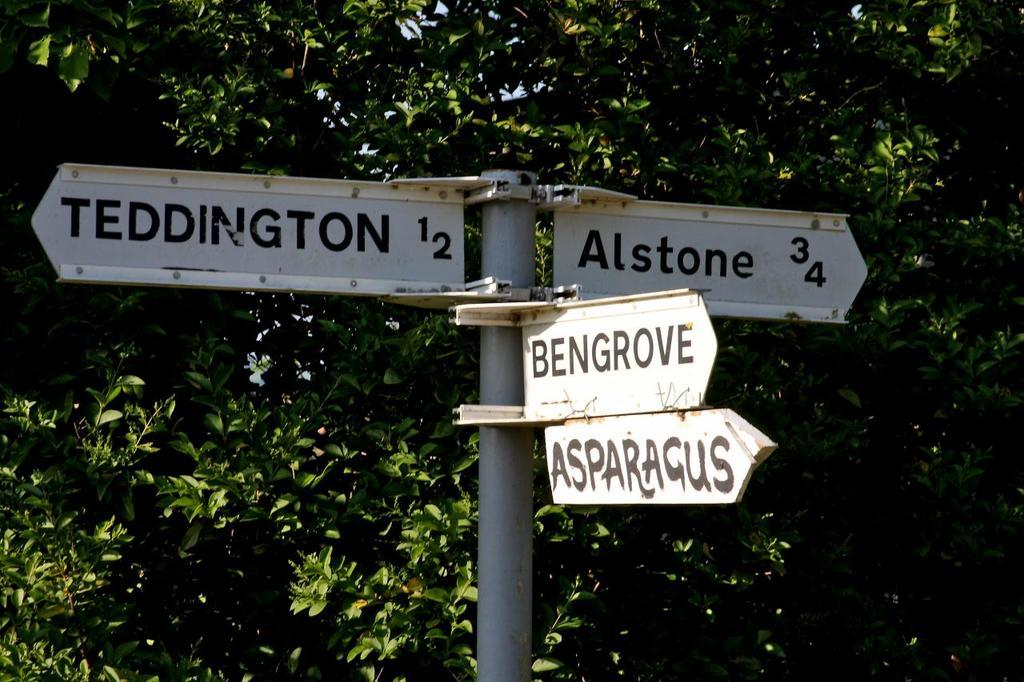What is attached to the pole in the image? There are boards fixed to a pole in the image. What can be seen in the background of the image? There are trees in the background of the image. What type of lipstick is the lawyer wearing in the image? There is no lawyer or lipstick present in the image; it only features boards fixed to a pole and trees in the background. 